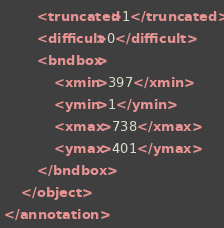<code> <loc_0><loc_0><loc_500><loc_500><_XML_>		<truncated>1</truncated>
		<difficult>0</difficult>
		<bndbox>
			<xmin>397</xmin>
			<ymin>1</ymin>
			<xmax>738</xmax>
			<ymax>401</ymax>
		</bndbox>
	</object>
</annotation>
</code> 